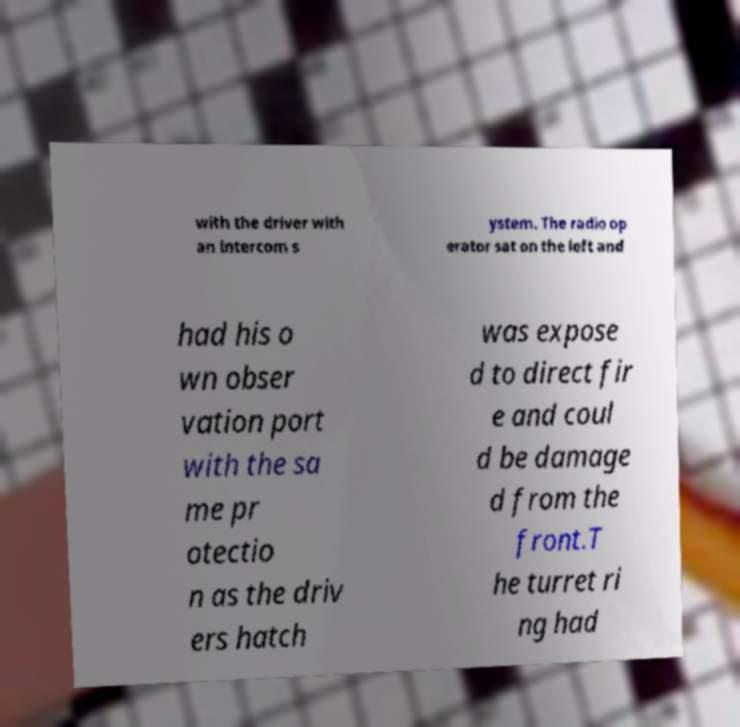Can you accurately transcribe the text from the provided image for me? with the driver with an intercom s ystem. The radio op erator sat on the left and had his o wn obser vation port with the sa me pr otectio n as the driv ers hatch was expose d to direct fir e and coul d be damage d from the front.T he turret ri ng had 